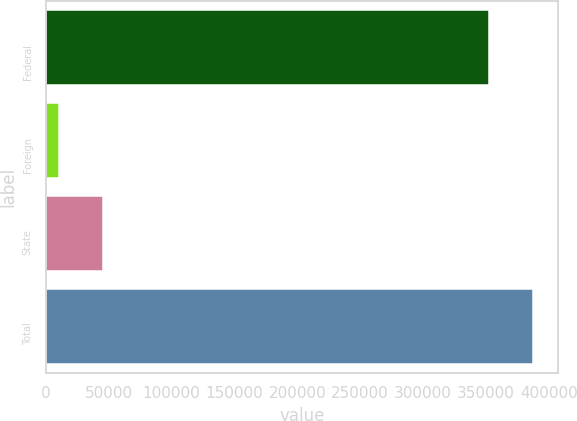Convert chart to OTSL. <chart><loc_0><loc_0><loc_500><loc_500><bar_chart><fcel>Federal<fcel>Foreign<fcel>State<fcel>Total<nl><fcel>352433<fcel>10625<fcel>45932.2<fcel>387740<nl></chart> 